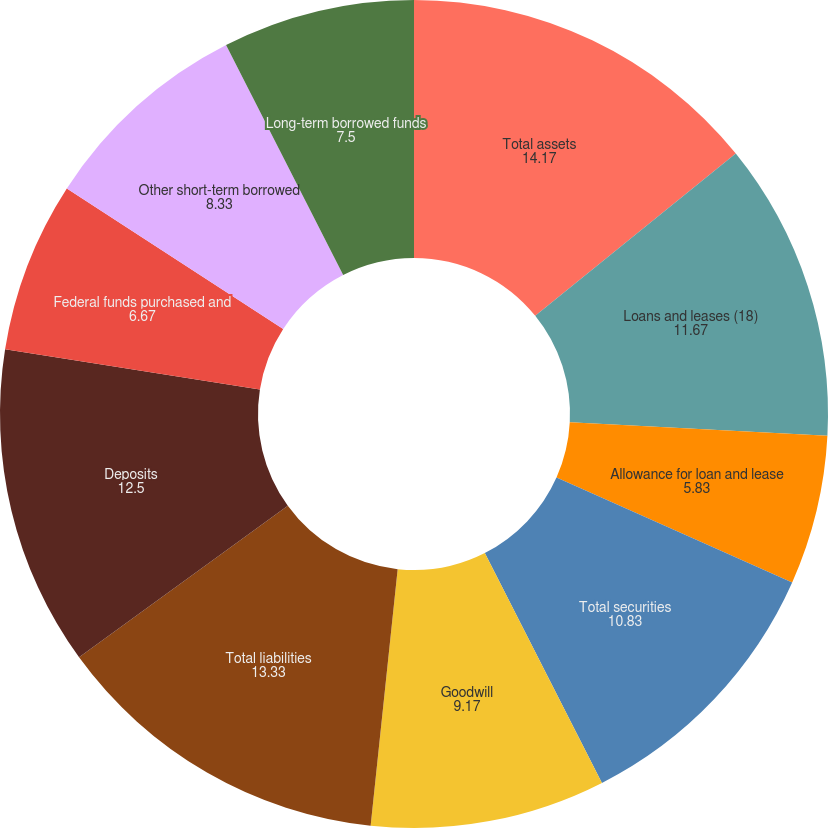Convert chart to OTSL. <chart><loc_0><loc_0><loc_500><loc_500><pie_chart><fcel>Total assets<fcel>Loans and leases (18)<fcel>Allowance for loan and lease<fcel>Total securities<fcel>Goodwill<fcel>Total liabilities<fcel>Deposits<fcel>Federal funds purchased and<fcel>Other short-term borrowed<fcel>Long-term borrowed funds<nl><fcel>14.17%<fcel>11.67%<fcel>5.83%<fcel>10.83%<fcel>9.17%<fcel>13.33%<fcel>12.5%<fcel>6.67%<fcel>8.33%<fcel>7.5%<nl></chart> 